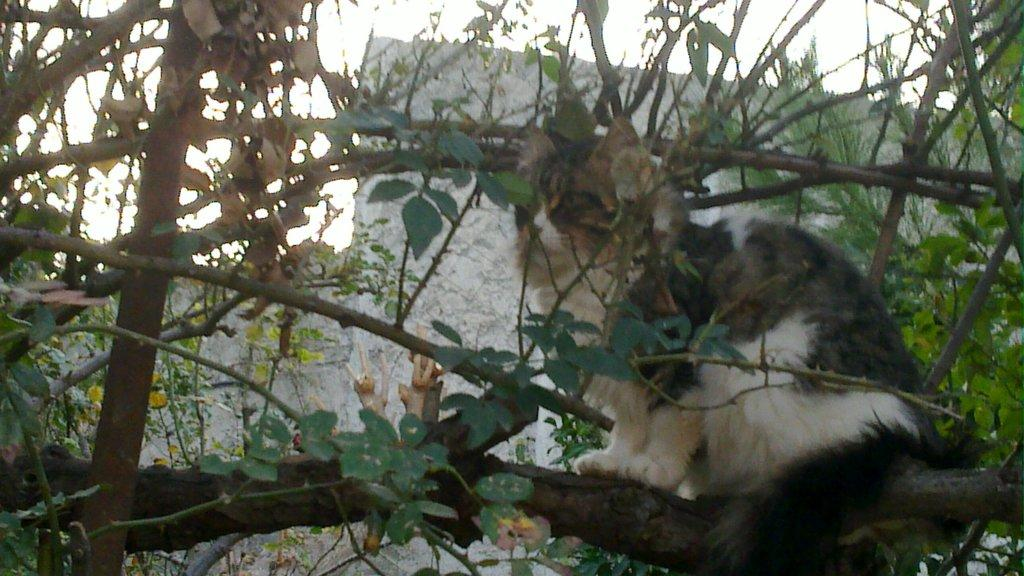What type of plant can be seen in the image? There is a tree in the image. What animal is sitting on the tree? A cat is sitting on the tree. What type of structure is visible in the image? There is a wall in the image. What part of the natural environment is visible in the image? The sky is visible in the image. What type of crime is being committed by the cat in the image? There is no crime being committed in the image; it simply shows a cat sitting on a tree. How many cushions are present in the image? There are no cushions present in the image. 